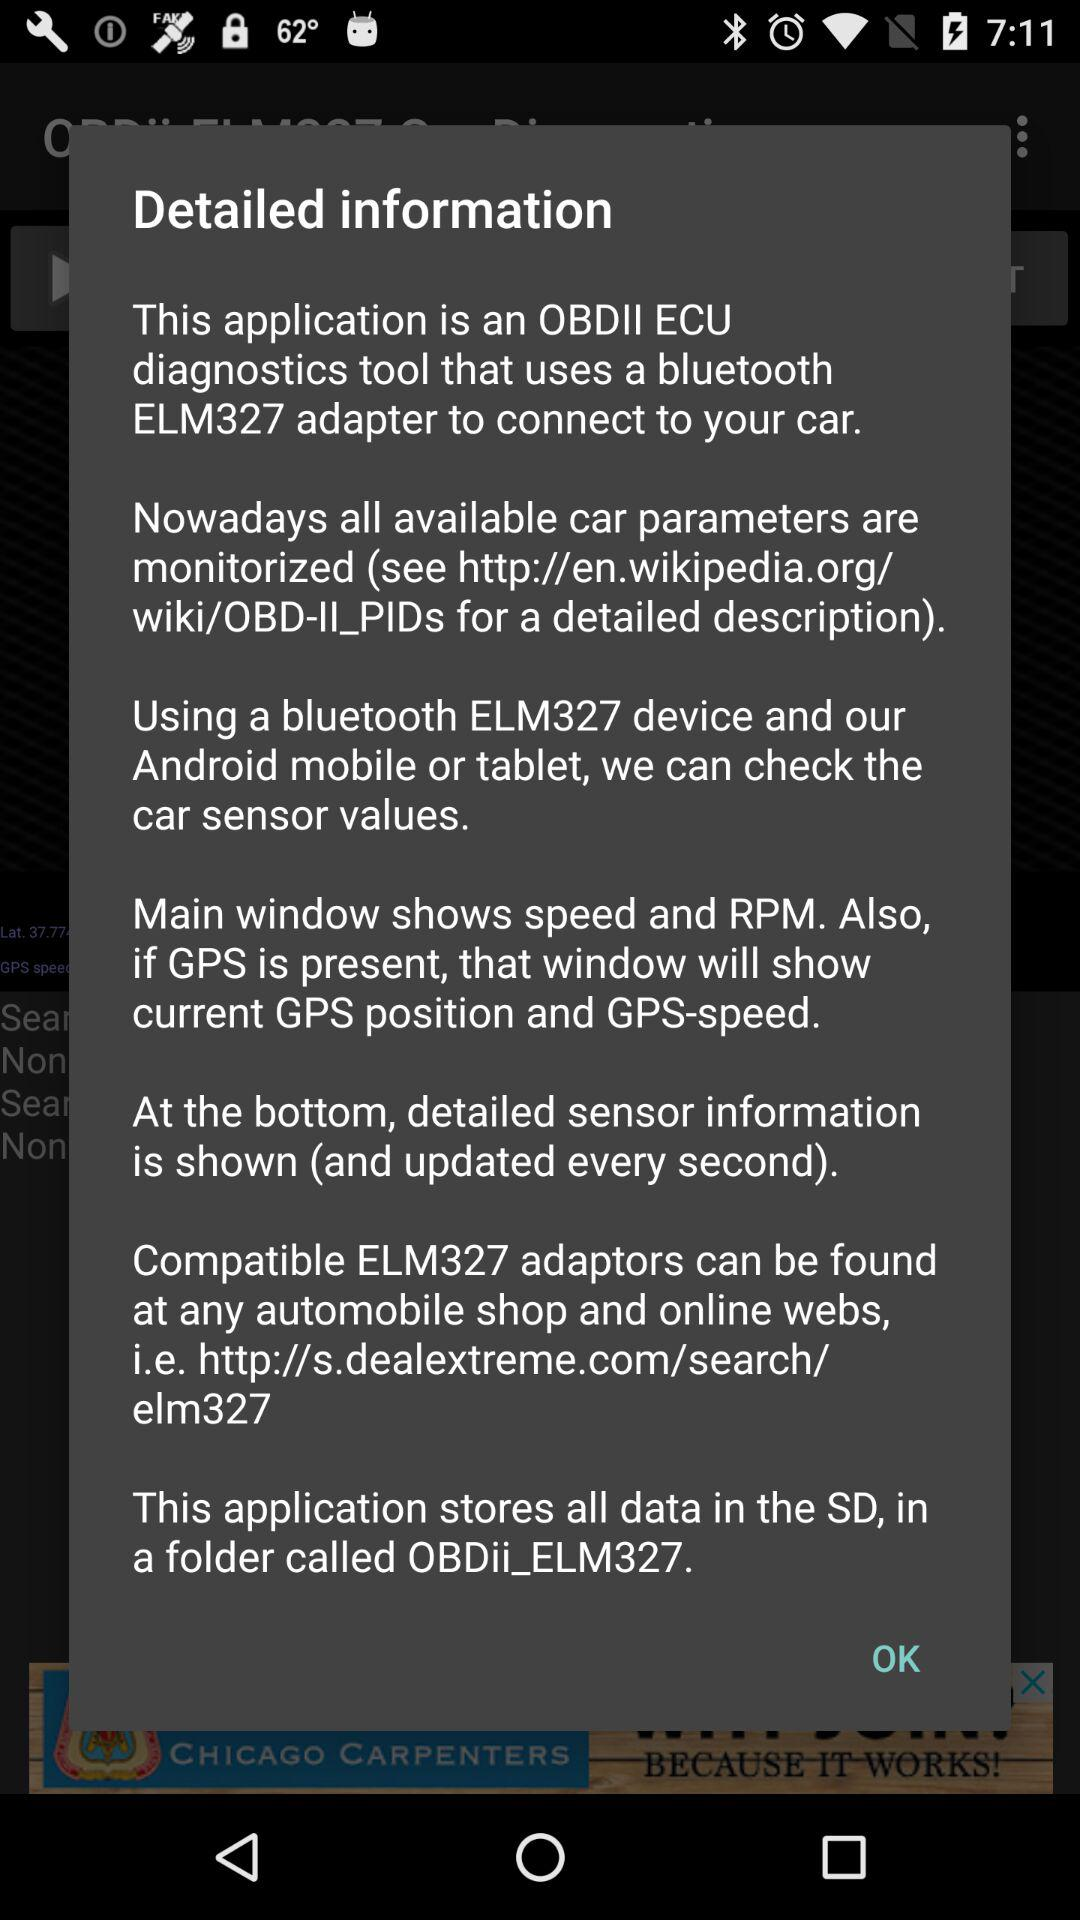What is the version of this application?
When the provided information is insufficient, respond with <no answer>. <no answer> 